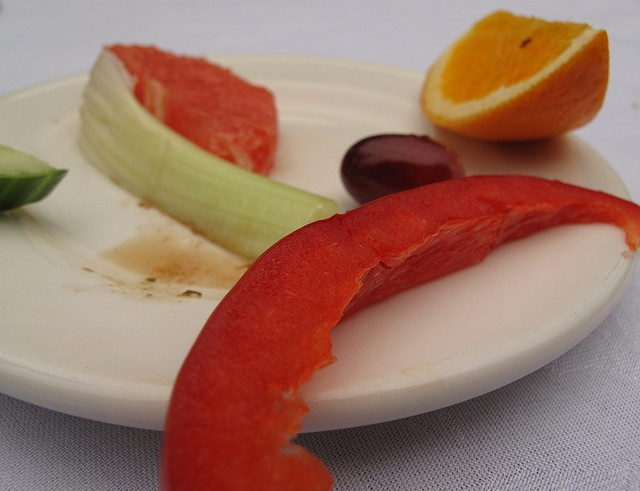Describe the objects in this image and their specific colors. I can see dining table in darkgray, brown, tan, and gray tones and orange in darkgray, red, maroon, and tan tones in this image. 